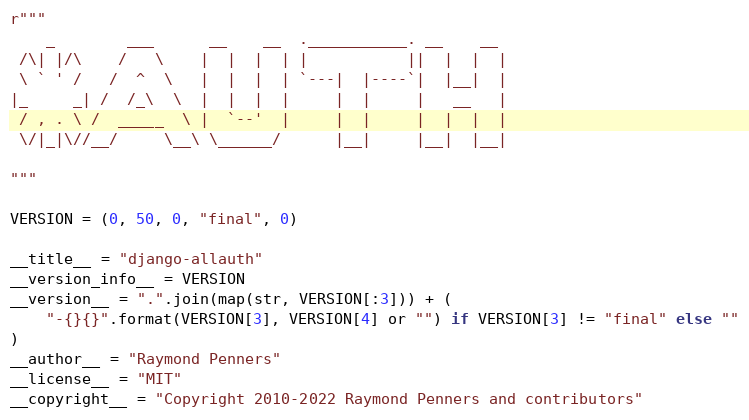<code> <loc_0><loc_0><loc_500><loc_500><_Python_>r"""
    _        ___      __    __  .___________. __    __
 /\| |/\    /   \    |  |  |  | |           ||  |  |  |
 \ ` ' /   /  ^  \   |  |  |  | `---|  |----`|  |__|  |
|_     _| /  /_\  \  |  |  |  |     |  |     |   __   |
 / , . \ /  _____  \ |  `--'  |     |  |     |  |  |  |
 \/|_|\//__/     \__\ \______/      |__|     |__|  |__|

"""

VERSION = (0, 50, 0, "final", 0)

__title__ = "django-allauth"
__version_info__ = VERSION
__version__ = ".".join(map(str, VERSION[:3])) + (
    "-{}{}".format(VERSION[3], VERSION[4] or "") if VERSION[3] != "final" else ""
)
__author__ = "Raymond Penners"
__license__ = "MIT"
__copyright__ = "Copyright 2010-2022 Raymond Penners and contributors"
</code> 